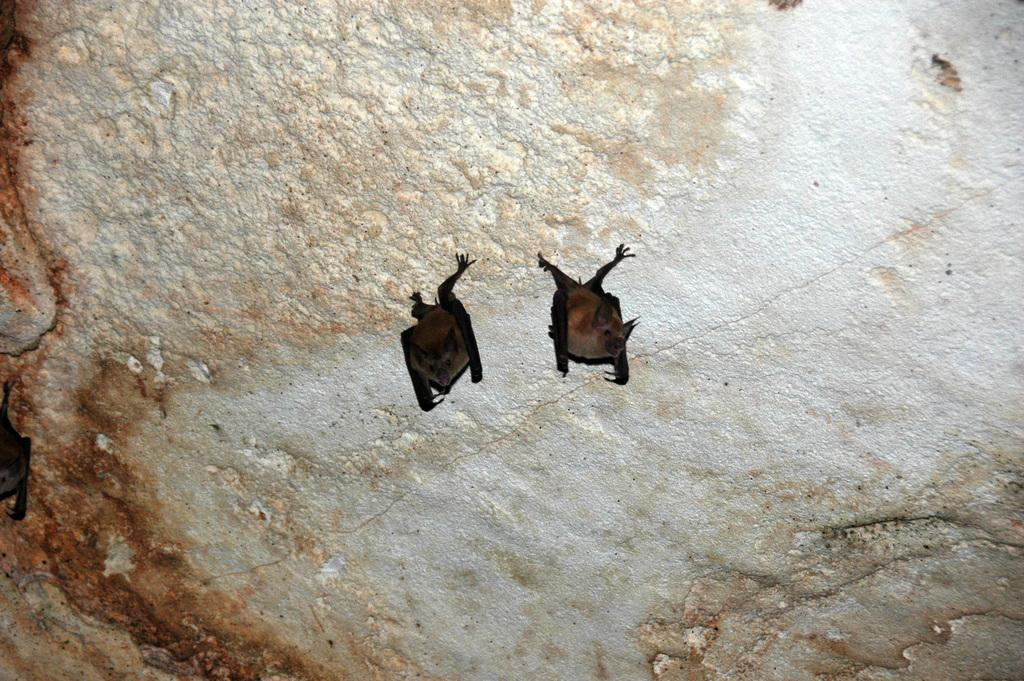What animals are present in the image? There are two bats in the image. What colors can be seen on the bats? The bats are in brown and black colors. What other object is visible in the image? There is a rock visible in the image. What type of harmony is being played by the bats in the image? There is no indication of music or harmony in the image; it features two bats and a rock. 